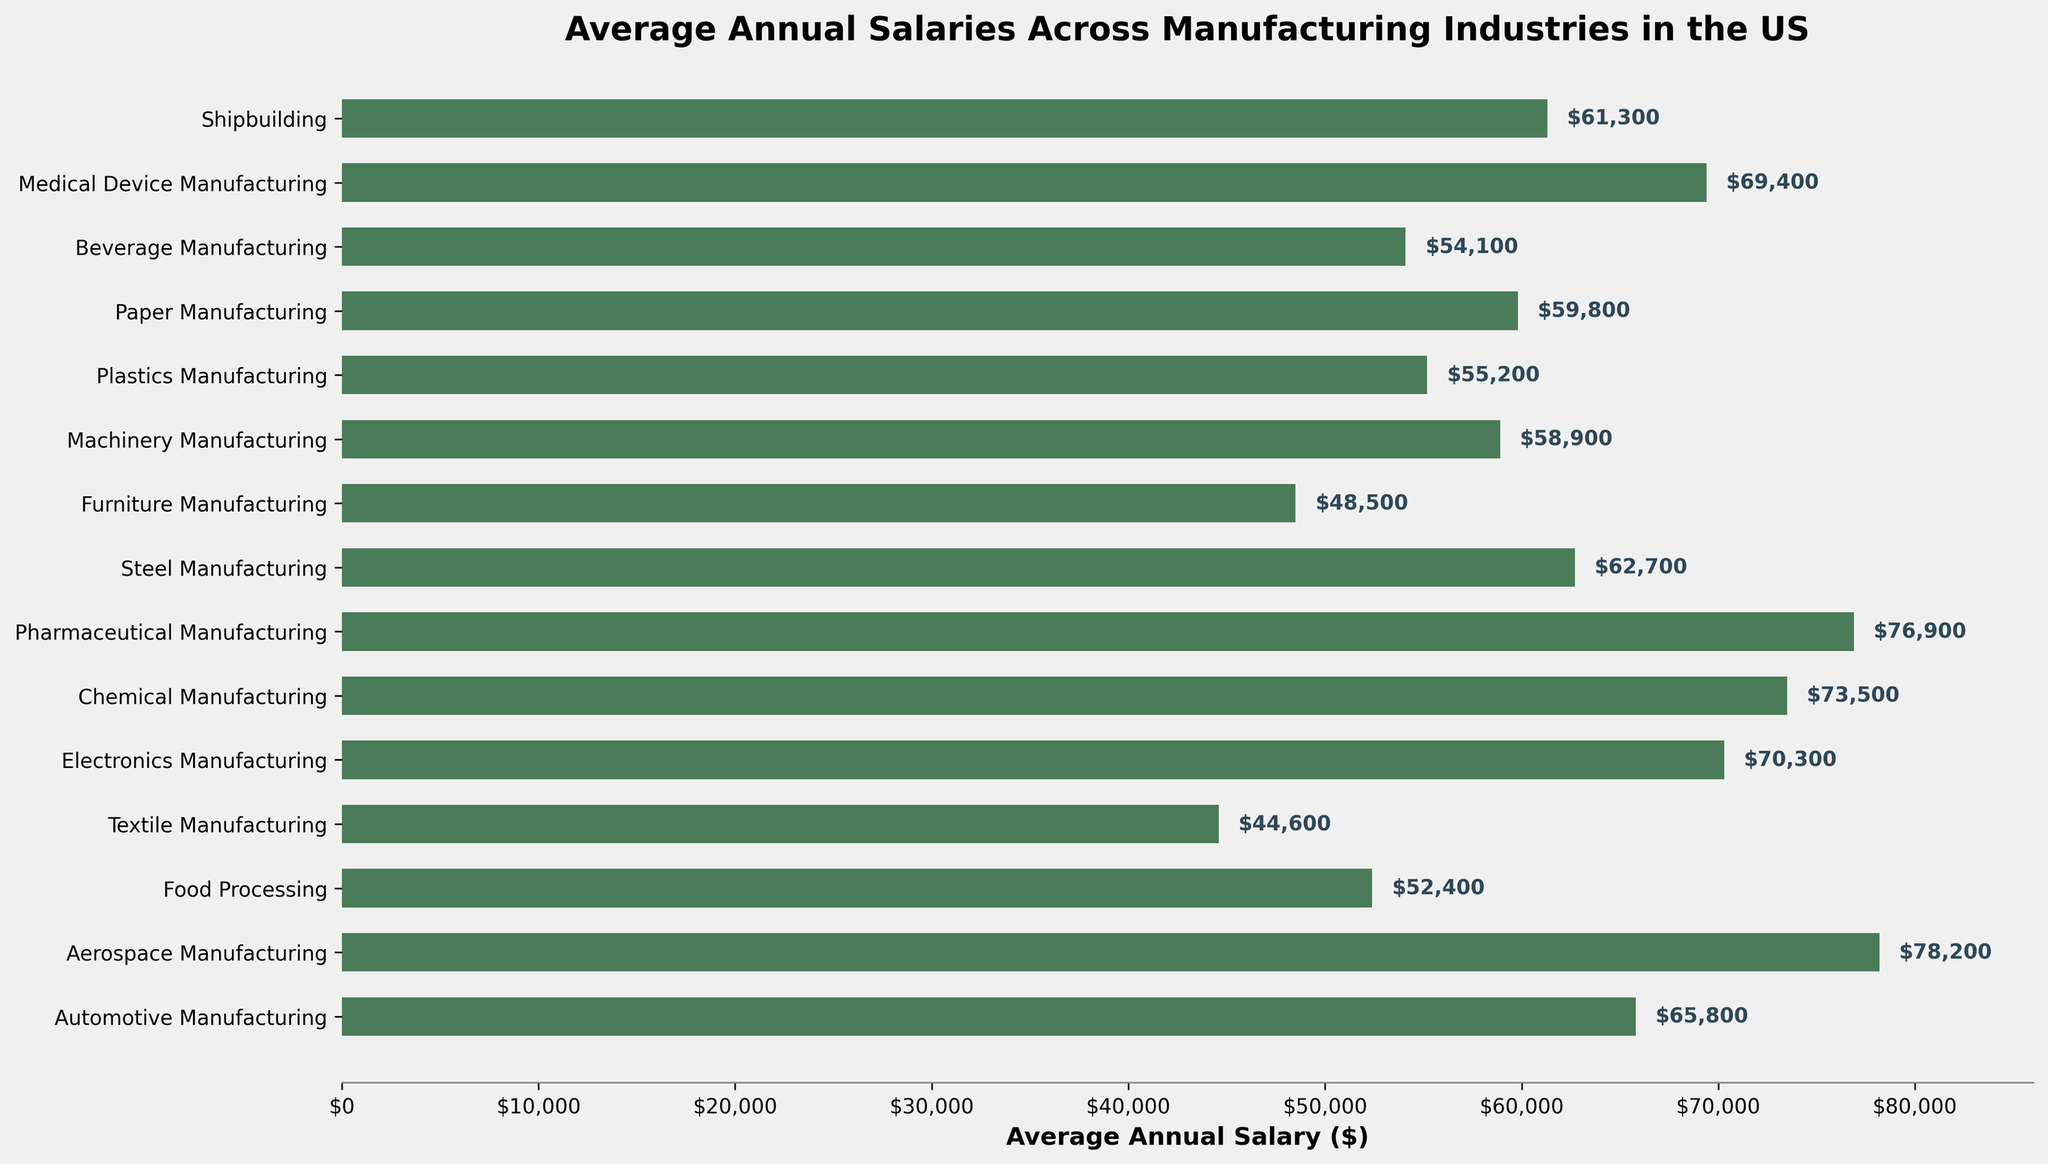Which industry has the highest average annual salary? The figure shows various manufacturing industries and their respective average annual salaries. The highest bar corresponds to Aerospace Manufacturing.
Answer: Aerospace Manufacturing What is the average annual salary difference between Aerospace Manufacturing and Textile Manufacturing? The average annual salary for Aerospace Manufacturing is $78,200, and for Textile Manufacturing, it is $44,600. Subtracting these gives a difference of $78,200 - $44,600 = $33,600.
Answer: $33,600 Which industries have average annual salaries greater than $70,000? Observing the figure, the industries with average annual salaries greater than $70,000 are Aerospace Manufacturing ($78,200), Electronics Manufacturing ($70,300), Chemical Manufacturing ($73,500), and Pharmaceutical Manufacturing ($76,900).
Answer: Aerospace Manufacturing, Electronics Manufacturing, Chemical Manufacturing, Pharmaceutical Manufacturing Which industry has the lowest average annual salary, and what is it? The lowest bar corresponds to Textile Manufacturing, which has an average annual salary of $44,600.
Answer: Textile Manufacturing, $44,600 How much higher is the average salary in Medical Device Manufacturing compared to Furniture Manufacturing? The average salary in Medical Device Manufacturing is $69,400, and in Furniture Manufacturing, it is $48,500. Subtracting these gives a difference of $69,400 - $48,500 = $20,900.
Answer: $20,900 Calculate the average annual salary for the industries in the middle range (from Machinery Manufacturing to Shipbuilding). The industries in the middle range include Machinery Manufacturing ($58,900), Plastics Manufacturing ($55,200), Paper Manufacturing ($59,800), Beverage Manufacturing ($54,100), and Shipbuilding ($61,300). Adding these up: $58,900 + $55,200 + $59,800 + $54,100 + $61,300 = $289,300. Dividing by 5 gives an average of $289,300 / 5 = $57,860.
Answer: $57,860 Are there any industries with an average annual salary around $65,000? If so, which ones? Observing the figure, the industry that is closest to $65,000 is Automotive Manufacturing with an average annual salary of $65,800.
Answer: Automotive Manufacturing How does the average salary in Steel Manufacturing compare to that in Paper Manufacturing? The average annual salary in Steel Manufacturing is $62,700, while in Paper Manufacturing, it is $59,800. This means the salary in Steel Manufacturing is slightly higher by $62,700 - $59,800 = $2,900.
Answer: Steel Manufacturing is $2,900 higher than Paper Manufacturing What is the difference between the average salaries of the highest and lowest-paid industries? The highest-paid industry is Aerospace Manufacturing ($78,200), and the lowest-paid industry is Textile Manufacturing ($44,600). The difference is $78,200 - $44,600 = $33,600.
Answer: $33,600 